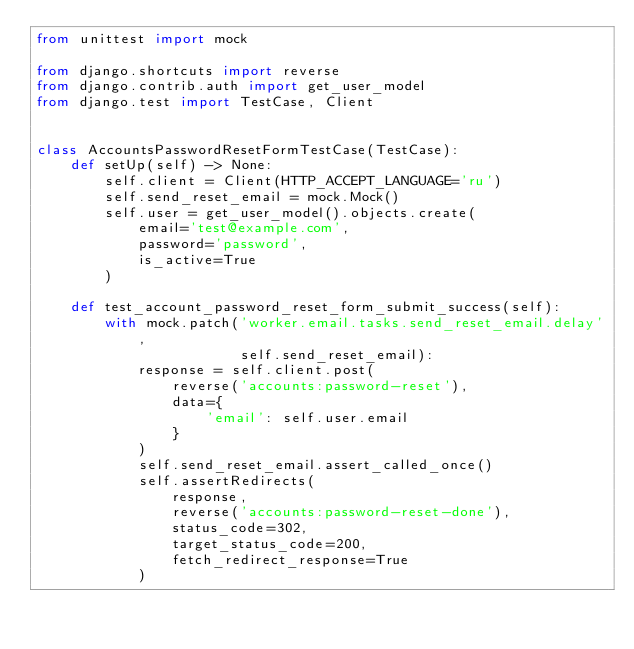<code> <loc_0><loc_0><loc_500><loc_500><_Python_>from unittest import mock

from django.shortcuts import reverse
from django.contrib.auth import get_user_model
from django.test import TestCase, Client


class AccountsPasswordResetFormTestCase(TestCase):
    def setUp(self) -> None:
        self.client = Client(HTTP_ACCEPT_LANGUAGE='ru')
        self.send_reset_email = mock.Mock()
        self.user = get_user_model().objects.create(
            email='test@example.com',
            password='password',
            is_active=True
        )

    def test_account_password_reset_form_submit_success(self):
        with mock.patch('worker.email.tasks.send_reset_email.delay',
                        self.send_reset_email):
            response = self.client.post(
                reverse('accounts:password-reset'),
                data={
                    'email': self.user.email
                }
            )
            self.send_reset_email.assert_called_once()
            self.assertRedirects(
                response,
                reverse('accounts:password-reset-done'),
                status_code=302,
                target_status_code=200,
                fetch_redirect_response=True
            )
</code> 